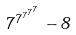Convert formula to latex. <formula><loc_0><loc_0><loc_500><loc_500>7 ^ { 7 ^ { 7 ^ { 7 ^ { 7 } } } } - 8</formula> 